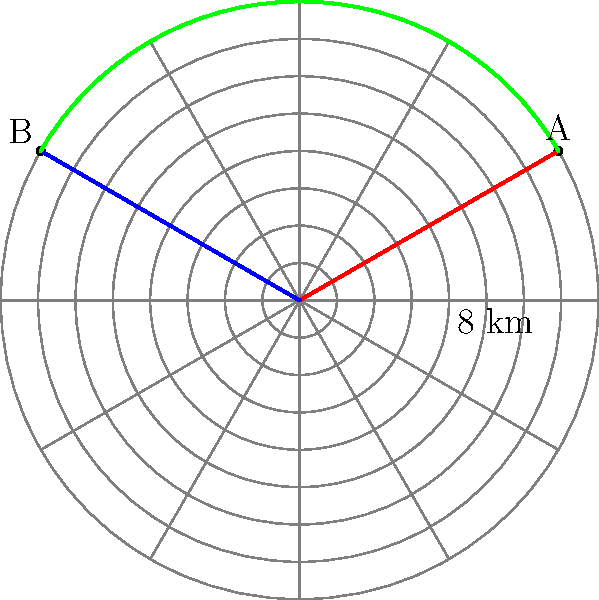As a logistics manager, you need to calculate the shortest distance between two Mercedes dealerships located on a polar grid. Dealership A is at coordinates $(8, \frac{\pi}{6})$ and Dealership B is at $(8, \frac{5\pi}{6})$. What is the length of the arc connecting these two dealerships, rounded to the nearest kilometer? To solve this problem, we'll follow these steps:

1) The dealerships are on the same circle with radius 8 km.

2) The angular difference between the dealerships is:
   $\Delta \theta = \frac{5\pi}{6} - \frac{\pi}{6} = \frac{4\pi}{6} = \frac{2\pi}{3}$

3) The arc length formula is: $s = r\theta$, where $r$ is the radius and $\theta$ is the angle in radians.

4) Substituting our values:
   $s = 8 \cdot \frac{2\pi}{3}$

5) Simplify:
   $s = \frac{16\pi}{3} \approx 16.755$ km

6) Rounding to the nearest kilometer:
   $s \approx 17$ km

Therefore, the shortest distance between the two dealerships along the arc is approximately 17 km.
Answer: 17 km 